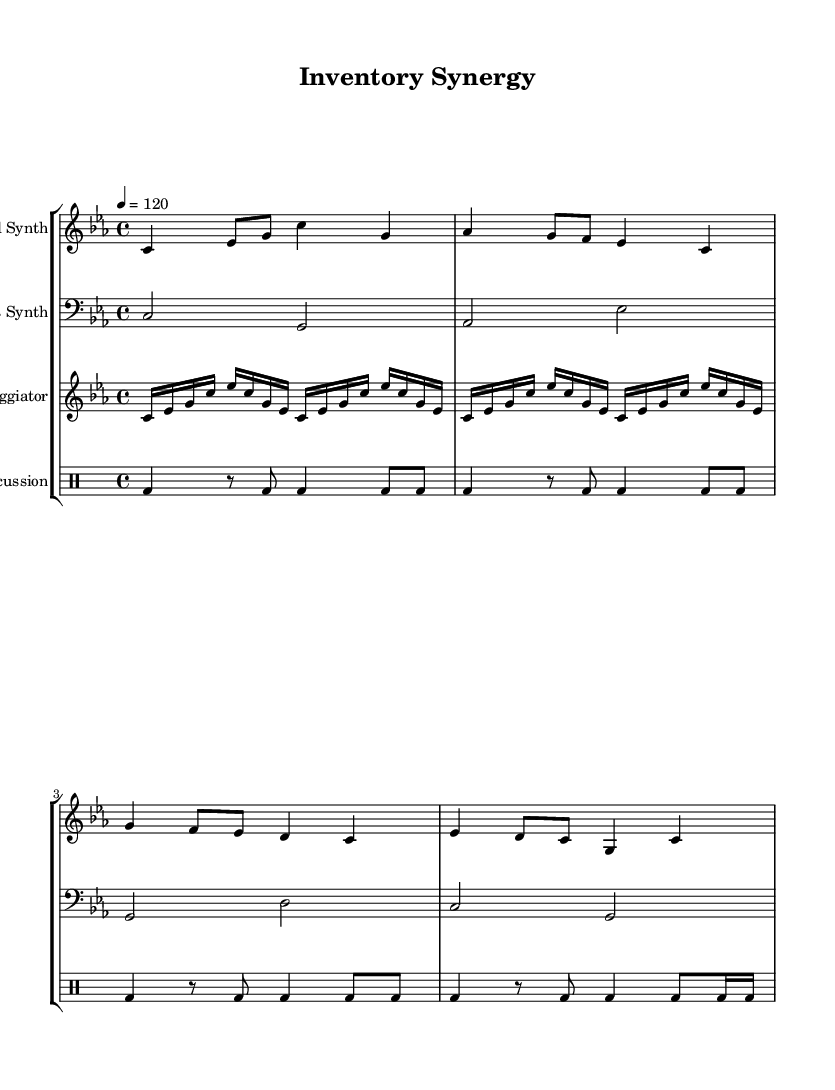What is the key signature of this music? The key signature indicates it is in C minor, which contains three flats: B flat, E flat, and A flat. This is determined by looking at the key signature located at the beginning of the staff.
Answer: C minor What is the time signature of this music? The time signature is indicated at the beginning as 4/4, meaning there are four beats in each measure and the quarter note receives one beat. This can be confirmed by observing the numbers placed at the start of the staff.
Answer: 4/4 What is the tempo marking for this piece? The tempo marking is provided as quarter note equals 120 beats per minute, shown in the tempo indication at the beginning of the score.
Answer: 120 How many measures are in the lead synth part? By counting the individual measure lines in the lead synth staff, we find that there are four measures total in this part.
Answer: 4 What is the primary instrumentation indicated in the score? The score contains four parts: Lead Synth, Bass Synth, Arpeggiator, and Percussion. This can be determined by noting the instrument names indicated at the start of each staff.
Answer: Lead Synth, Bass Synth, Arpeggiator, Percussion How many notes are in the first measure of the lead synth? The first measure of the lead synth contains four notes, specifically the notes C, E flat, G, and C, as each note is clearly represented within the first measure's bar line.
Answer: 4 What type of rhythm is predominantly used in the percussion part? The percussion part predominantly utilizes a bass drum rhythm, which consists primarily of quarter notes and some eighth notes throughout the section. This can be determined by analyzing the notation in the drum staff.
Answer: Bass drum 